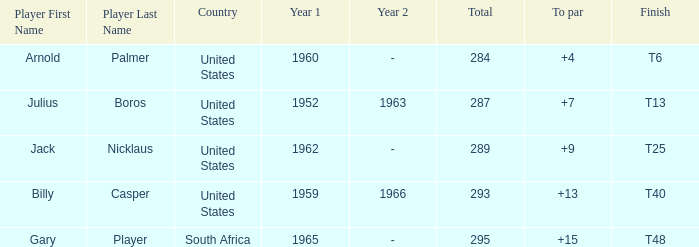Which player from the United States won in 1962? Jack Nicklaus. 